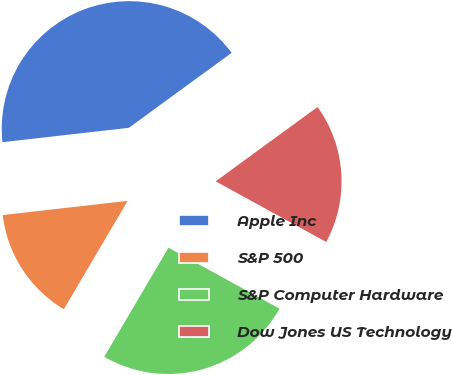<chart> <loc_0><loc_0><loc_500><loc_500><pie_chart><fcel>Apple Inc<fcel>S&P 500<fcel>S&P Computer Hardware<fcel>Dow Jones US Technology<nl><fcel>41.77%<fcel>14.73%<fcel>25.48%<fcel>18.02%<nl></chart> 